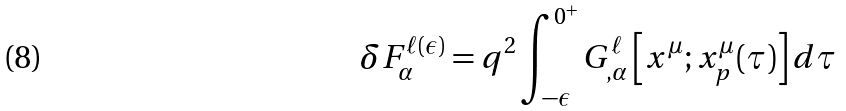<formula> <loc_0><loc_0><loc_500><loc_500>\delta F ^ { \ell ( \epsilon ) } _ { \alpha } = q ^ { 2 } \int _ { - \epsilon } ^ { 0 ^ { + } } G ^ { \ell } _ { , \alpha } \left [ x ^ { \mu } ; x _ { p } ^ { \mu } ( \tau ) \right ] d \tau</formula> 